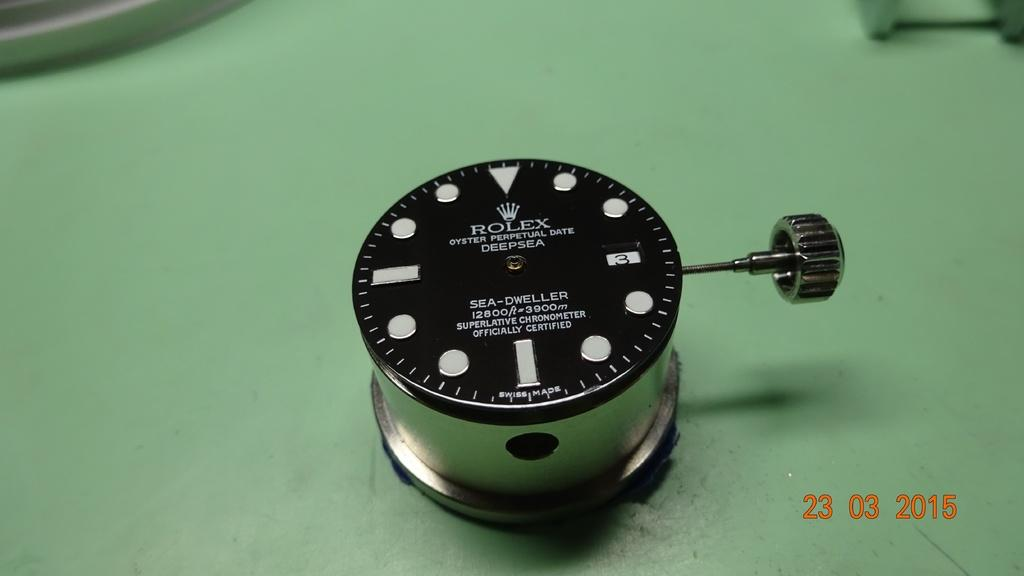<image>
Write a terse but informative summary of the picture. A rolex sea dweller is sitting on a green surface. 